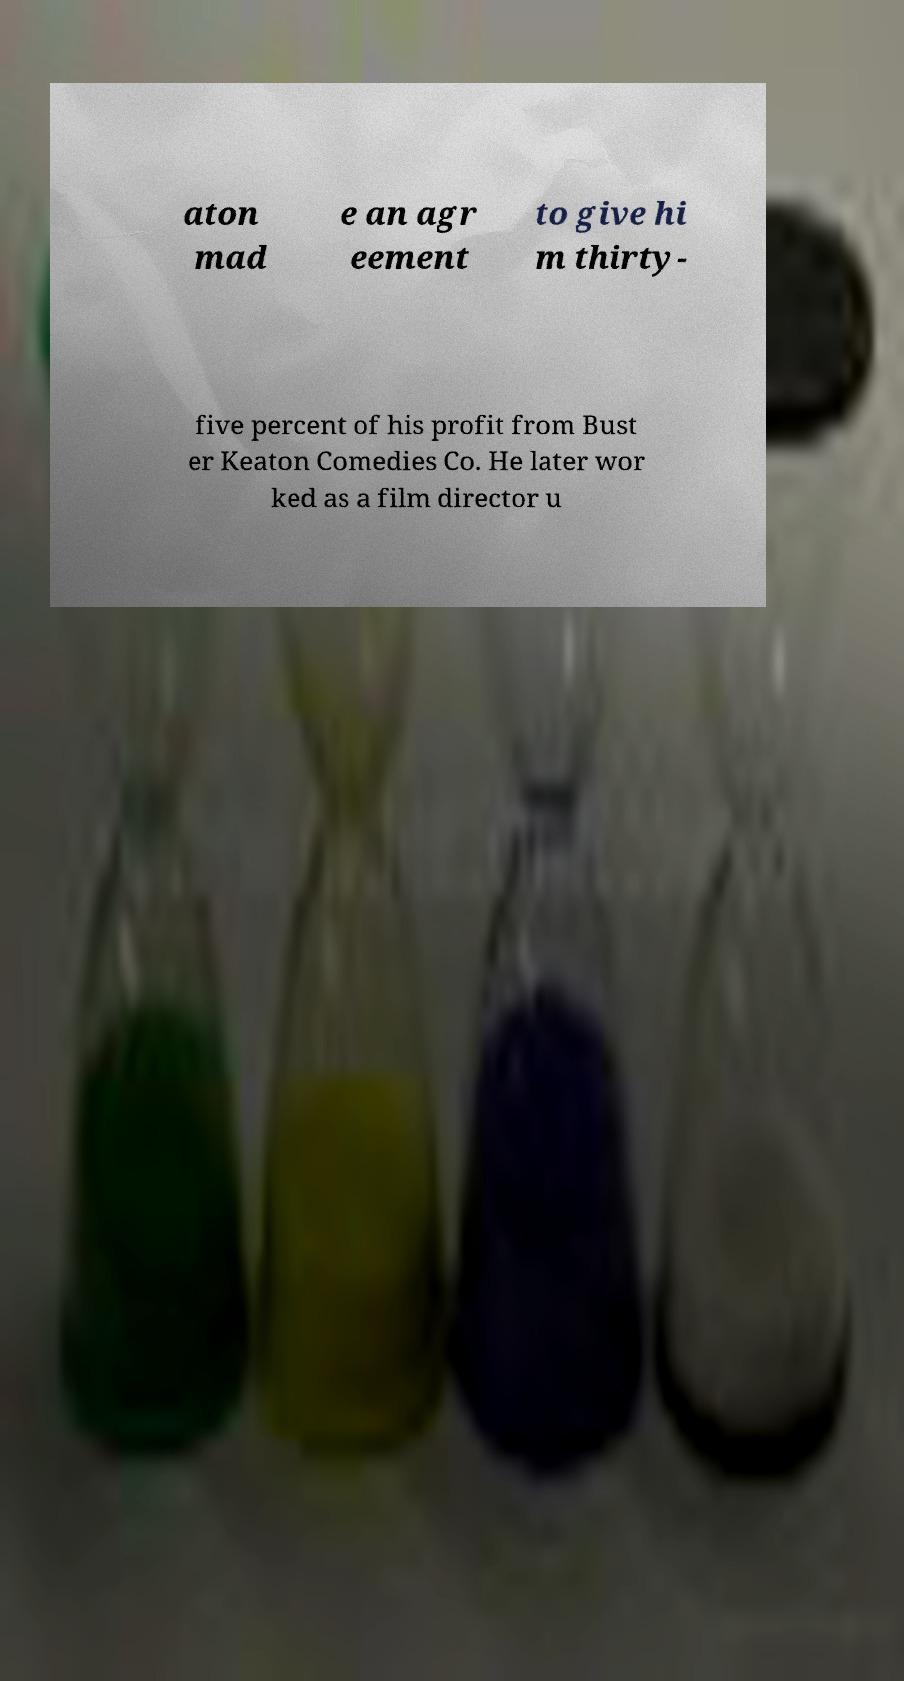There's text embedded in this image that I need extracted. Can you transcribe it verbatim? aton mad e an agr eement to give hi m thirty- five percent of his profit from Bust er Keaton Comedies Co. He later wor ked as a film director u 